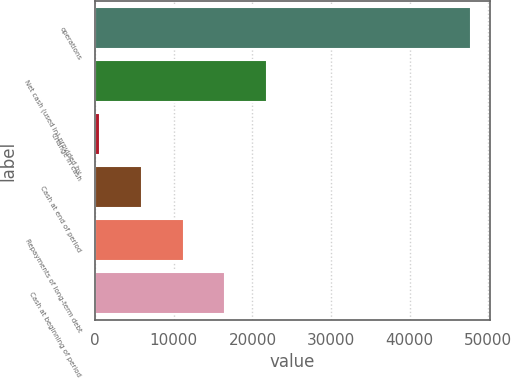Convert chart to OTSL. <chart><loc_0><loc_0><loc_500><loc_500><bar_chart><fcel>operations<fcel>Net cash (used in) provided by<fcel>Change in cash<fcel>Cash at end of period<fcel>Repayments of long-term debt<fcel>Cash at beginning of period<nl><fcel>47832<fcel>21853.2<fcel>670<fcel>5965.8<fcel>11261.6<fcel>16557.4<nl></chart> 